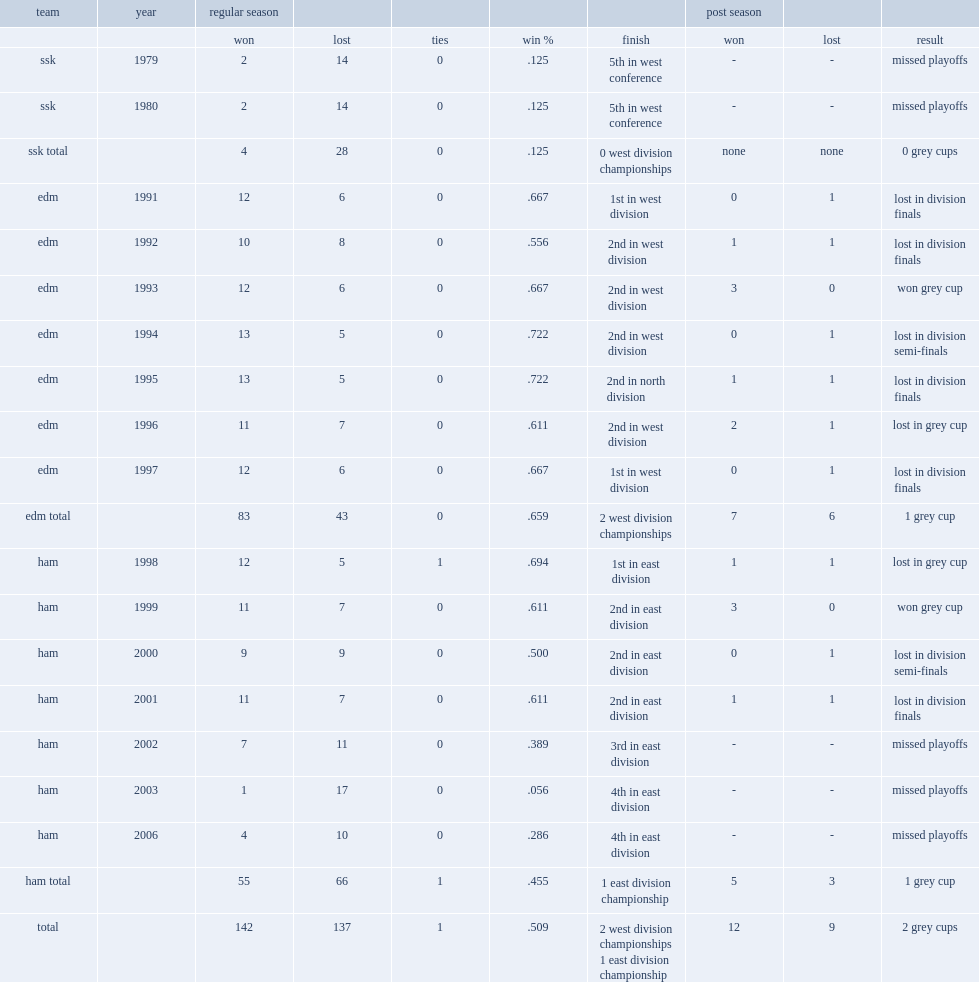What is the result of ron lancaster served as a head coach in the cfl? 2 grey cups. Write the full table. {'header': ['team', 'year', 'regular season', '', '', '', '', 'post season', '', ''], 'rows': [['', '', 'won', 'lost', 'ties', 'win %', 'finish', 'won', 'lost', 'result'], ['ssk', '1979', '2', '14', '0', '.125', '5th in west conference', '-', '-', 'missed playoffs'], ['ssk', '1980', '2', '14', '0', '.125', '5th in west conference', '-', '-', 'missed playoffs'], ['ssk total', '', '4', '28', '0', '.125', '0 west division championships', 'none', 'none', '0 grey cups'], ['edm', '1991', '12', '6', '0', '.667', '1st in west division', '0', '1', 'lost in division finals'], ['edm', '1992', '10', '8', '0', '.556', '2nd in west division', '1', '1', 'lost in division finals'], ['edm', '1993', '12', '6', '0', '.667', '2nd in west division', '3', '0', 'won grey cup'], ['edm', '1994', '13', '5', '0', '.722', '2nd in west division', '0', '1', 'lost in division semi-finals'], ['edm', '1995', '13', '5', '0', '.722', '2nd in north division', '1', '1', 'lost in division finals'], ['edm', '1996', '11', '7', '0', '.611', '2nd in west division', '2', '1', 'lost in grey cup'], ['edm', '1997', '12', '6', '0', '.667', '1st in west division', '0', '1', 'lost in division finals'], ['edm total', '', '83', '43', '0', '.659', '2 west division championships', '7', '6', '1 grey cup'], ['ham', '1998', '12', '5', '1', '.694', '1st in east division', '1', '1', 'lost in grey cup'], ['ham', '1999', '11', '7', '0', '.611', '2nd in east division', '3', '0', 'won grey cup'], ['ham', '2000', '9', '9', '0', '.500', '2nd in east division', '0', '1', 'lost in division semi-finals'], ['ham', '2001', '11', '7', '0', '.611', '2nd in east division', '1', '1', 'lost in division finals'], ['ham', '2002', '7', '11', '0', '.389', '3rd in east division', '-', '-', 'missed playoffs'], ['ham', '2003', '1', '17', '0', '.056', '4th in east division', '-', '-', 'missed playoffs'], ['ham', '2006', '4', '10', '0', '.286', '4th in east division', '-', '-', 'missed playoffs'], ['ham total', '', '55', '66', '1', '.455', '1 east division championship', '5', '3', '1 grey cup'], ['total', '', '142', '137', '1', '.509', '2 west division championships 1 east division championship', '12', '9', '2 grey cups']]} 